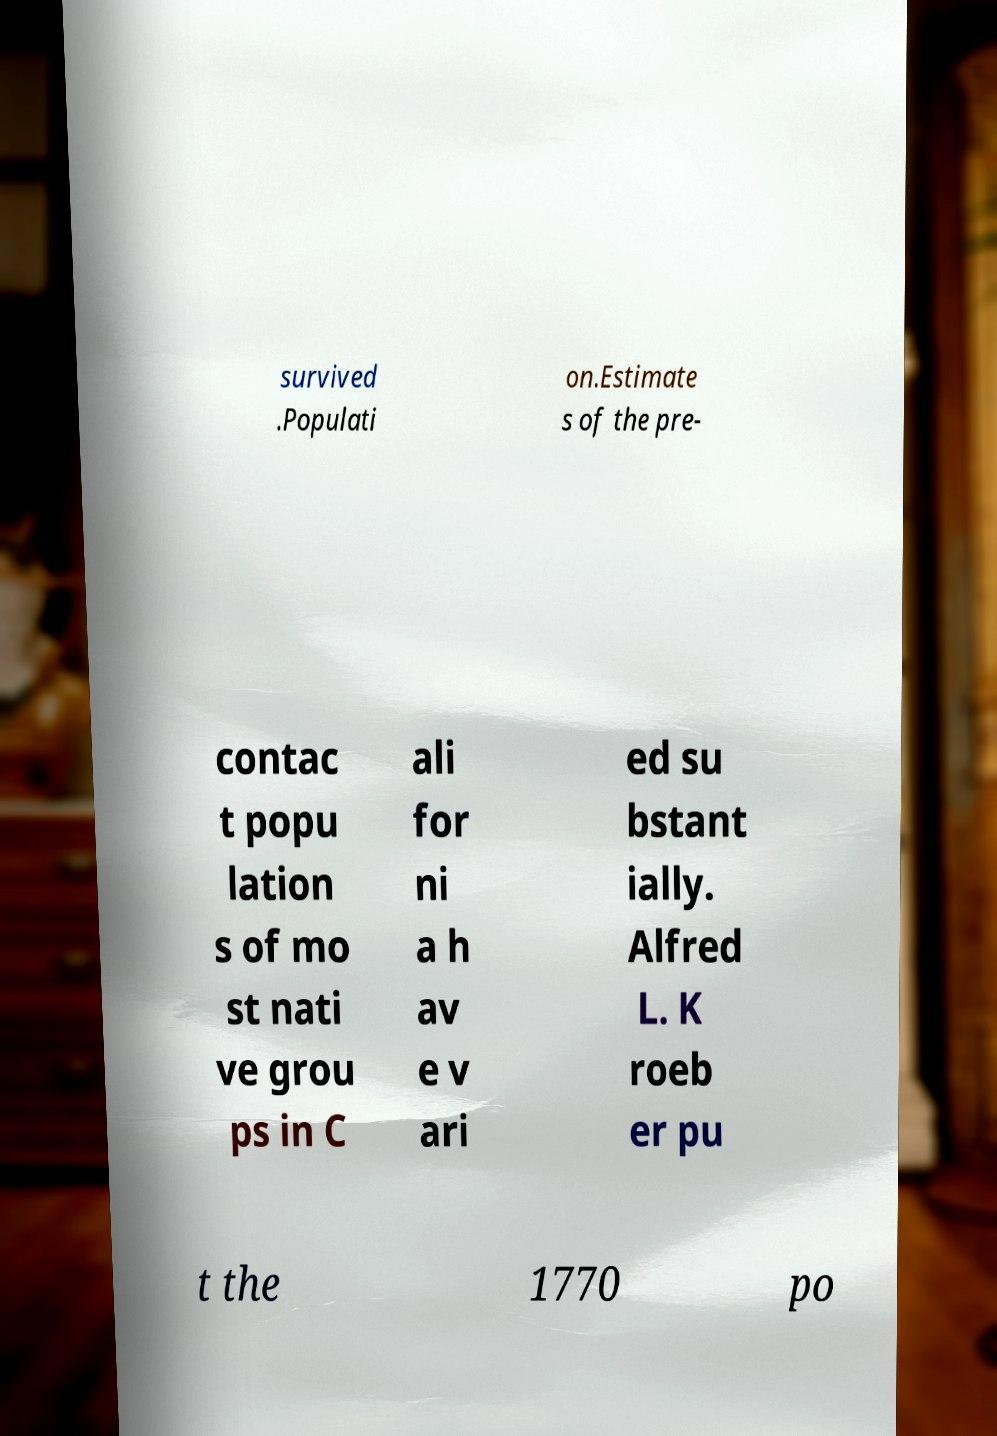What messages or text are displayed in this image? I need them in a readable, typed format. survived .Populati on.Estimate s of the pre- contac t popu lation s of mo st nati ve grou ps in C ali for ni a h av e v ari ed su bstant ially. Alfred L. K roeb er pu t the 1770 po 